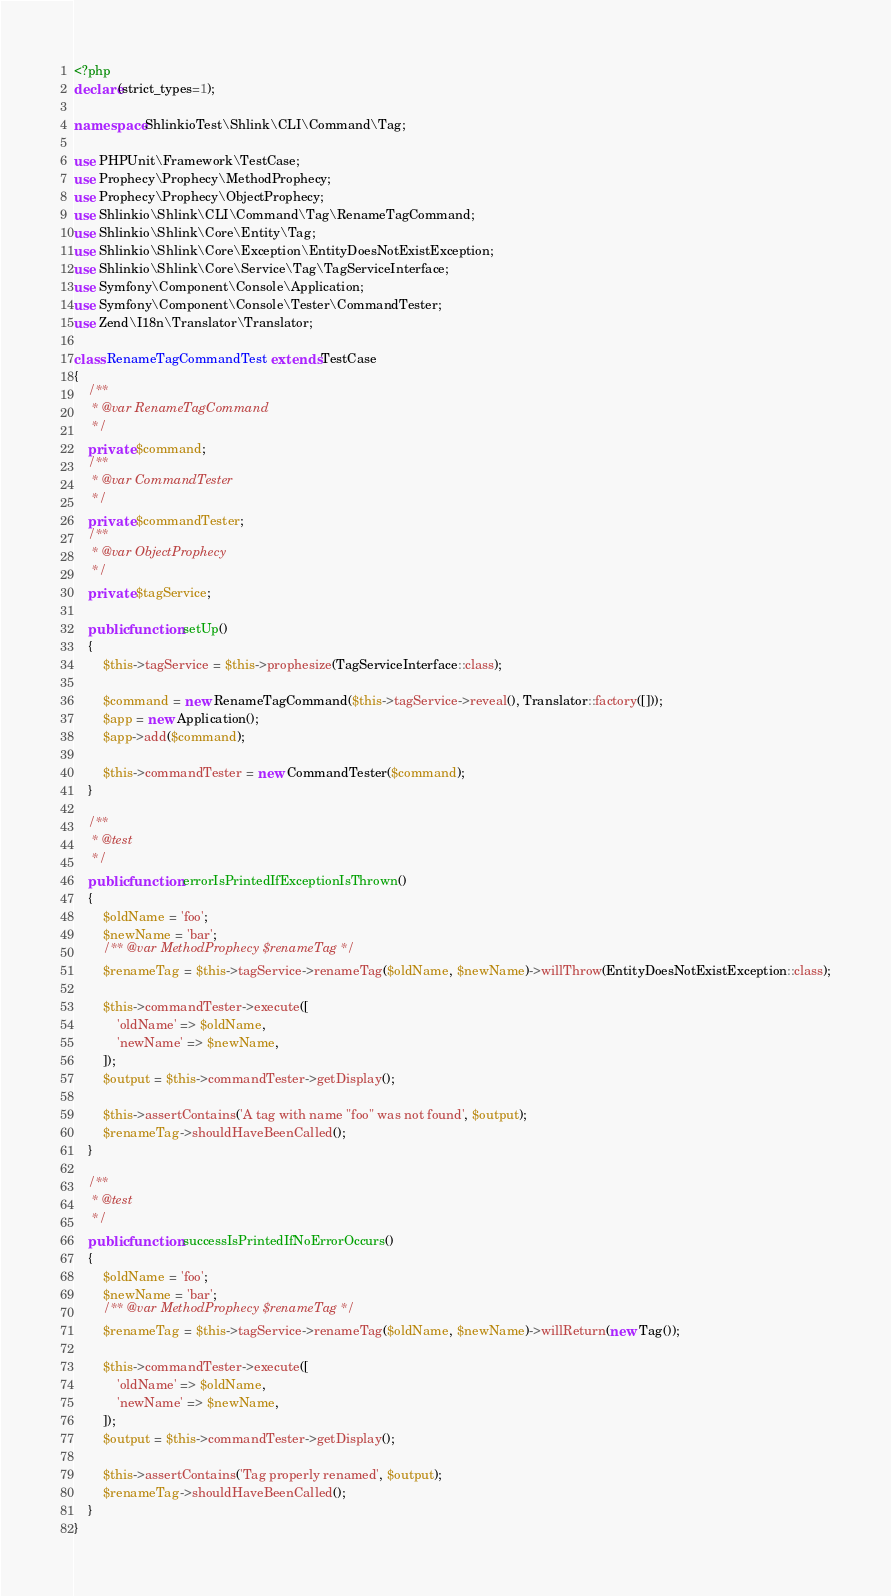<code> <loc_0><loc_0><loc_500><loc_500><_PHP_><?php
declare(strict_types=1);

namespace ShlinkioTest\Shlink\CLI\Command\Tag;

use PHPUnit\Framework\TestCase;
use Prophecy\Prophecy\MethodProphecy;
use Prophecy\Prophecy\ObjectProphecy;
use Shlinkio\Shlink\CLI\Command\Tag\RenameTagCommand;
use Shlinkio\Shlink\Core\Entity\Tag;
use Shlinkio\Shlink\Core\Exception\EntityDoesNotExistException;
use Shlinkio\Shlink\Core\Service\Tag\TagServiceInterface;
use Symfony\Component\Console\Application;
use Symfony\Component\Console\Tester\CommandTester;
use Zend\I18n\Translator\Translator;

class RenameTagCommandTest extends TestCase
{
    /**
     * @var RenameTagCommand
     */
    private $command;
    /**
     * @var CommandTester
     */
    private $commandTester;
    /**
     * @var ObjectProphecy
     */
    private $tagService;

    public function setUp()
    {
        $this->tagService = $this->prophesize(TagServiceInterface::class);

        $command = new RenameTagCommand($this->tagService->reveal(), Translator::factory([]));
        $app = new Application();
        $app->add($command);

        $this->commandTester = new CommandTester($command);
    }

    /**
     * @test
     */
    public function errorIsPrintedIfExceptionIsThrown()
    {
        $oldName = 'foo';
        $newName = 'bar';
        /** @var MethodProphecy $renameTag */
        $renameTag = $this->tagService->renameTag($oldName, $newName)->willThrow(EntityDoesNotExistException::class);

        $this->commandTester->execute([
            'oldName' => $oldName,
            'newName' => $newName,
        ]);
        $output = $this->commandTester->getDisplay();

        $this->assertContains('A tag with name "foo" was not found', $output);
        $renameTag->shouldHaveBeenCalled();
    }

    /**
     * @test
     */
    public function successIsPrintedIfNoErrorOccurs()
    {
        $oldName = 'foo';
        $newName = 'bar';
        /** @var MethodProphecy $renameTag */
        $renameTag = $this->tagService->renameTag($oldName, $newName)->willReturn(new Tag());

        $this->commandTester->execute([
            'oldName' => $oldName,
            'newName' => $newName,
        ]);
        $output = $this->commandTester->getDisplay();

        $this->assertContains('Tag properly renamed', $output);
        $renameTag->shouldHaveBeenCalled();
    }
}
</code> 